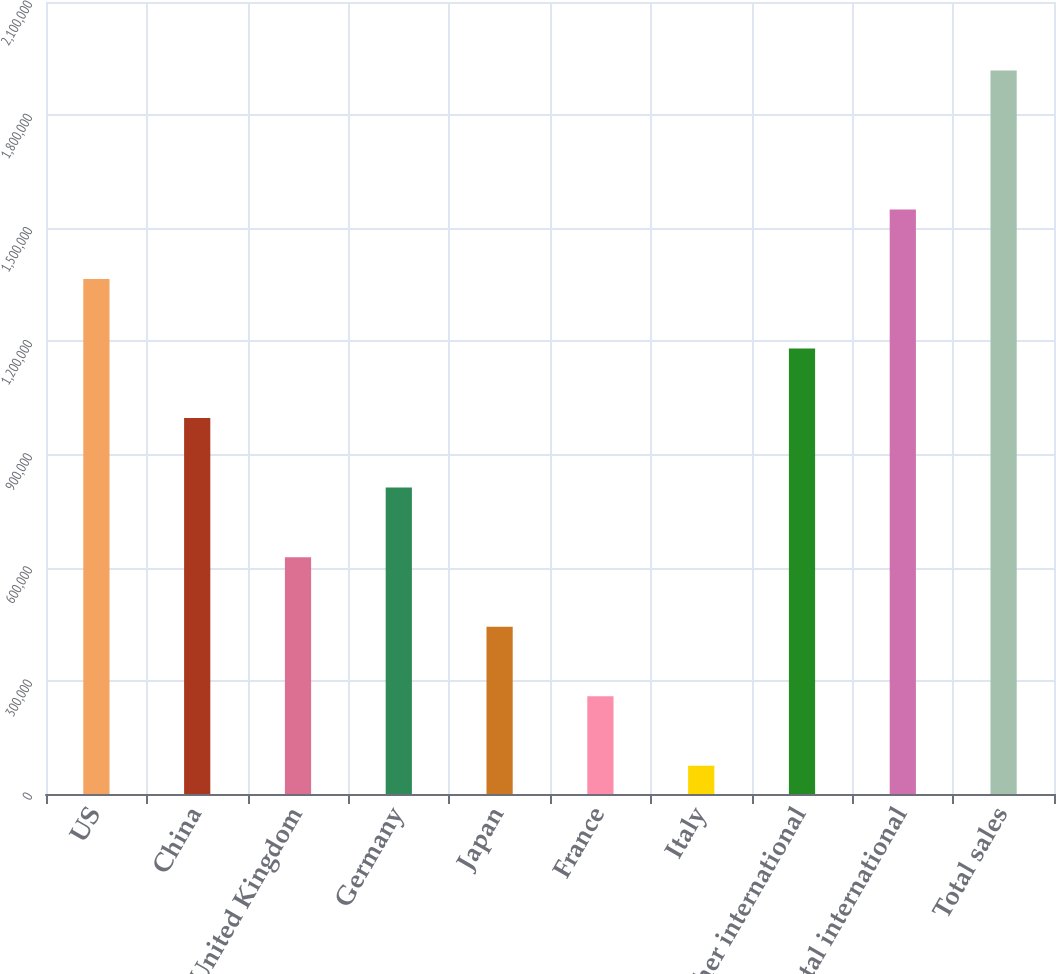<chart> <loc_0><loc_0><loc_500><loc_500><bar_chart><fcel>US<fcel>China<fcel>United Kingdom<fcel>Germany<fcel>Japan<fcel>France<fcel>Italy<fcel>Other international<fcel>Total international<fcel>Total sales<nl><fcel>1.36543e+06<fcel>996716<fcel>628000<fcel>812358<fcel>443642<fcel>259283<fcel>74925<fcel>1.18107e+06<fcel>1.54979e+06<fcel>1.91851e+06<nl></chart> 